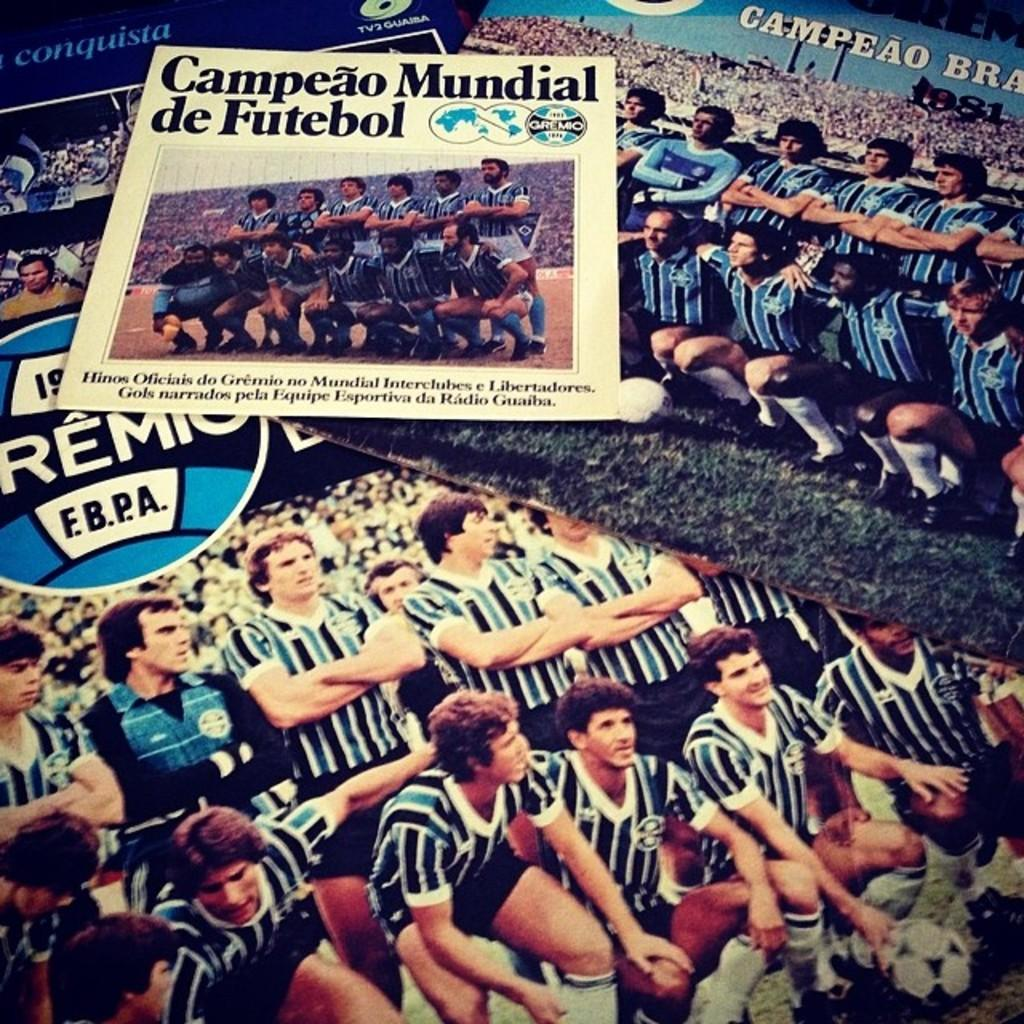What can be seen in the image that resembles a vertical structure? There are posts in the image. What is attached to the posts? The posts have posters on them. What is depicted on the posters? The posters contain images of people. What additional information can be found on the posters? The posters contain some information. Can you tell me how many buttons are attached to the posters in the image? There are no buttons mentioned or visible in the image; the posters contain images of people and some information. Is there a garden visible in the image? There is no mention of a garden in the provided facts, and no such setting is visible in the image. 